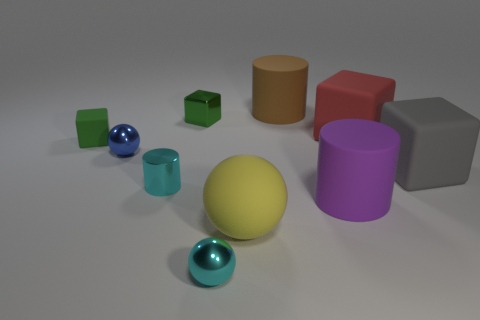Subtract 1 cubes. How many cubes are left? 3 Subtract all green cylinders. Subtract all purple spheres. How many cylinders are left? 3 Subtract all blocks. How many objects are left? 6 Add 1 cyan metal balls. How many cyan metal balls exist? 2 Subtract 1 purple cylinders. How many objects are left? 9 Subtract all matte cubes. Subtract all green matte objects. How many objects are left? 6 Add 8 large red things. How many large red things are left? 9 